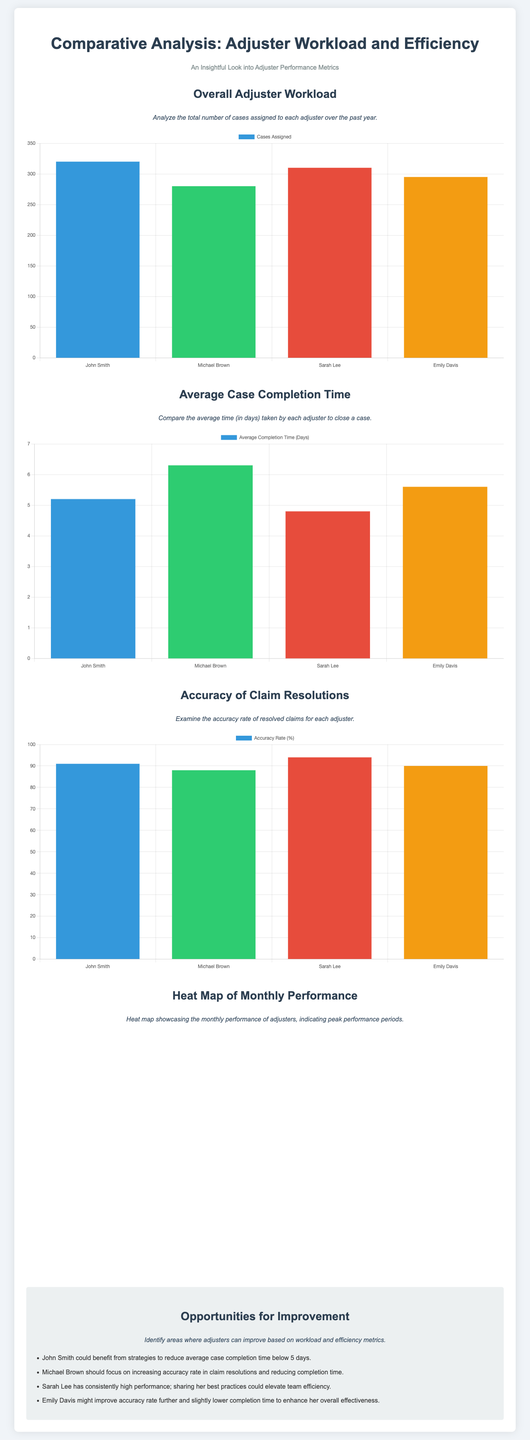What is the highest number of cases assigned to an adjuster? The highest number of cases assigned to an adjuster is 320, which belongs to John Smith.
Answer: 320 What is Sarah Lee's average case completion time in days? Sarah Lee's average case completion time is 4.8 days.
Answer: 4.8 Which adjuster has the highest accuracy rate for claim resolutions? The adjuster with the highest accuracy rate for claim resolutions is Sarah Lee, with a rate of 94%.
Answer: 94 Which month had the lowest performance for Michael Brown? The month with the lowest performance for Michael Brown is February, with a score of 80.
Answer: February What area could John Smith improve upon? John Smith could improve on his average case completion time, which is currently at 5.2 days.
Answer: Average case completion time Which adjuster consistently shows high performance? Sarah Lee consistently shows high performance.
Answer: Sarah Lee 